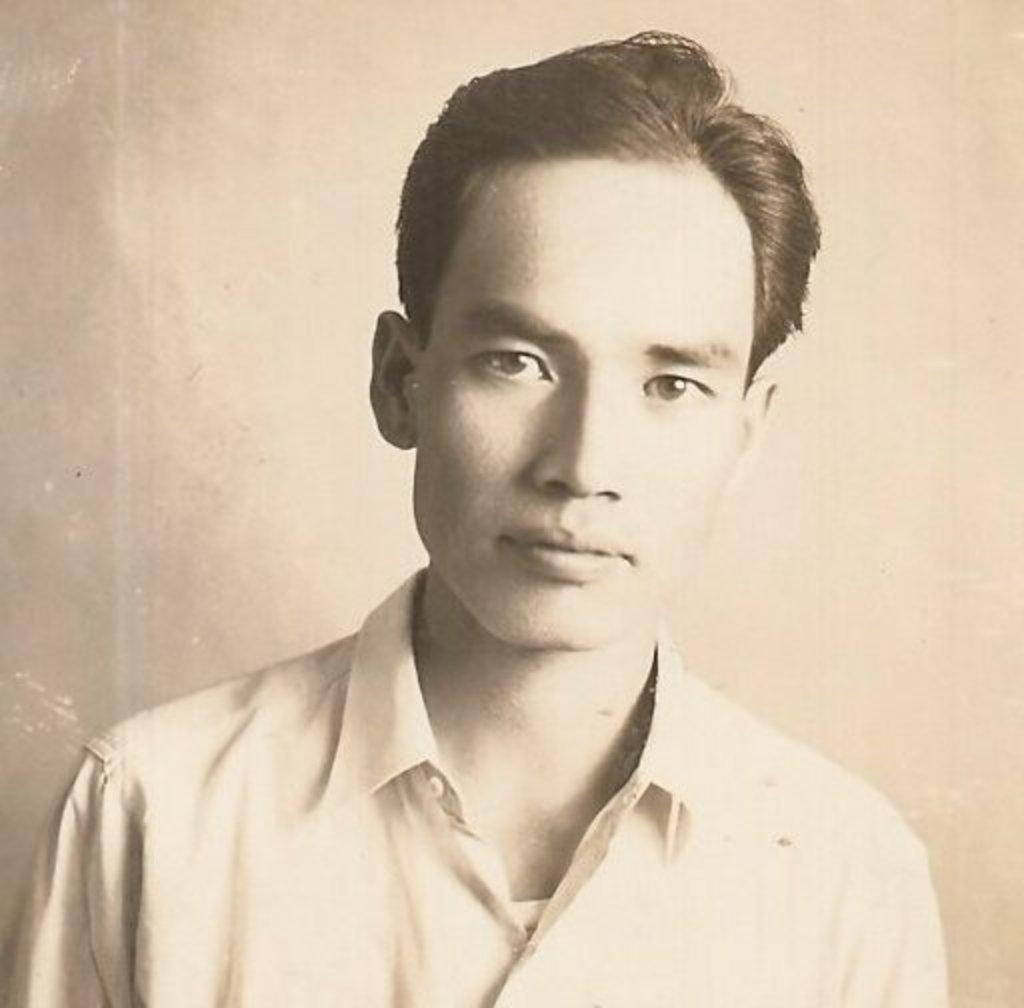What is the main subject of the image? There is a man in the image. What is the man wearing? The man is wearing a shirt. What can be seen behind the man in the image? There is a wall visible behind the man. What type of pot is the man using to fuel the battle in the image? There is no pot, fuel, or battle present in the image. The image only features a man wearing a shirt with a wall in the background. 